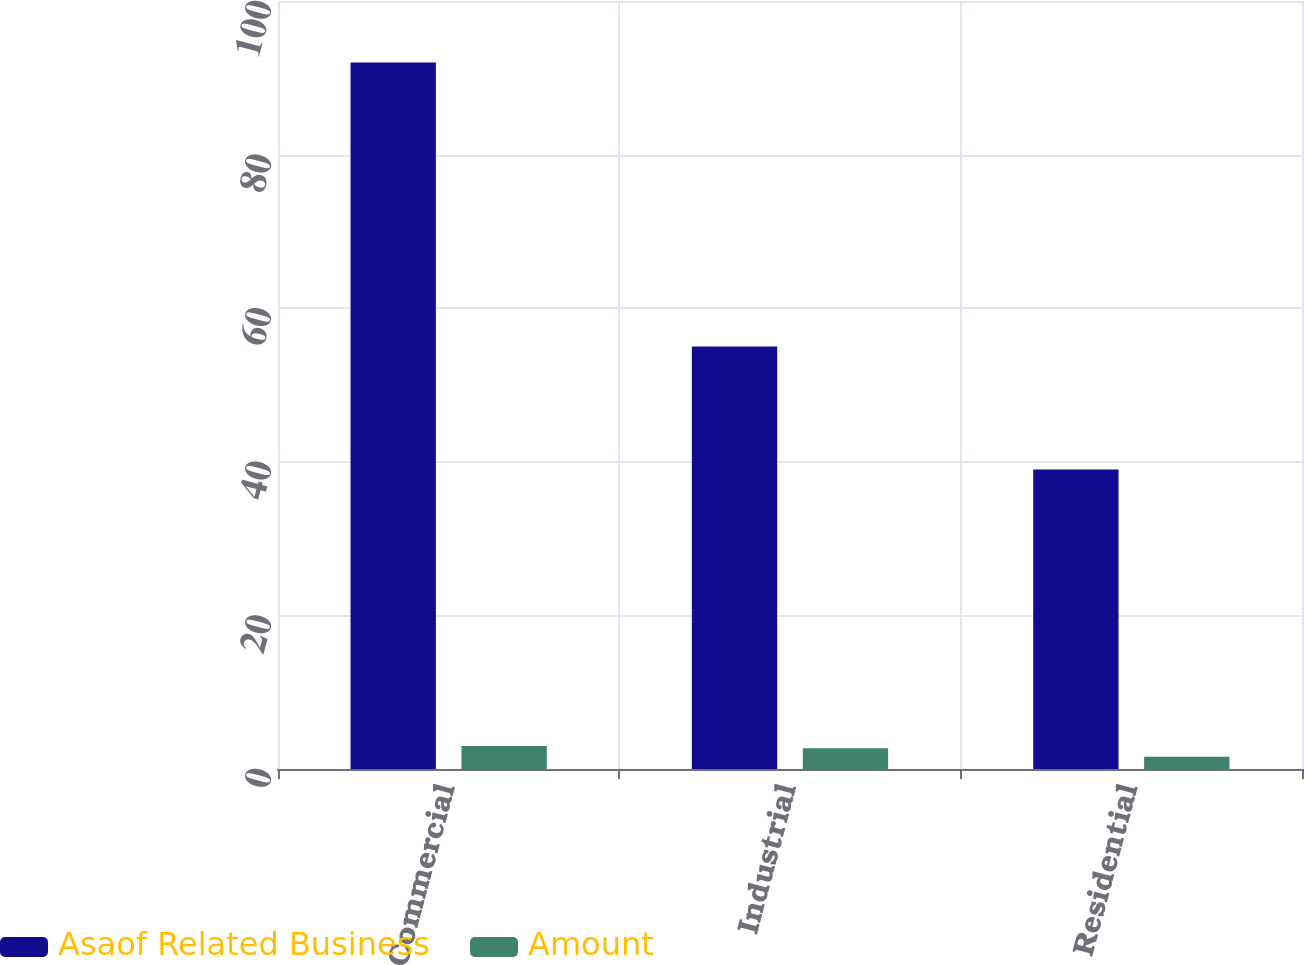Convert chart to OTSL. <chart><loc_0><loc_0><loc_500><loc_500><stacked_bar_chart><ecel><fcel>Commercial<fcel>Industrial<fcel>Residential<nl><fcel>Asaof Related Business<fcel>92<fcel>55<fcel>39<nl><fcel>Amount<fcel>3<fcel>2.7<fcel>1.6<nl></chart> 